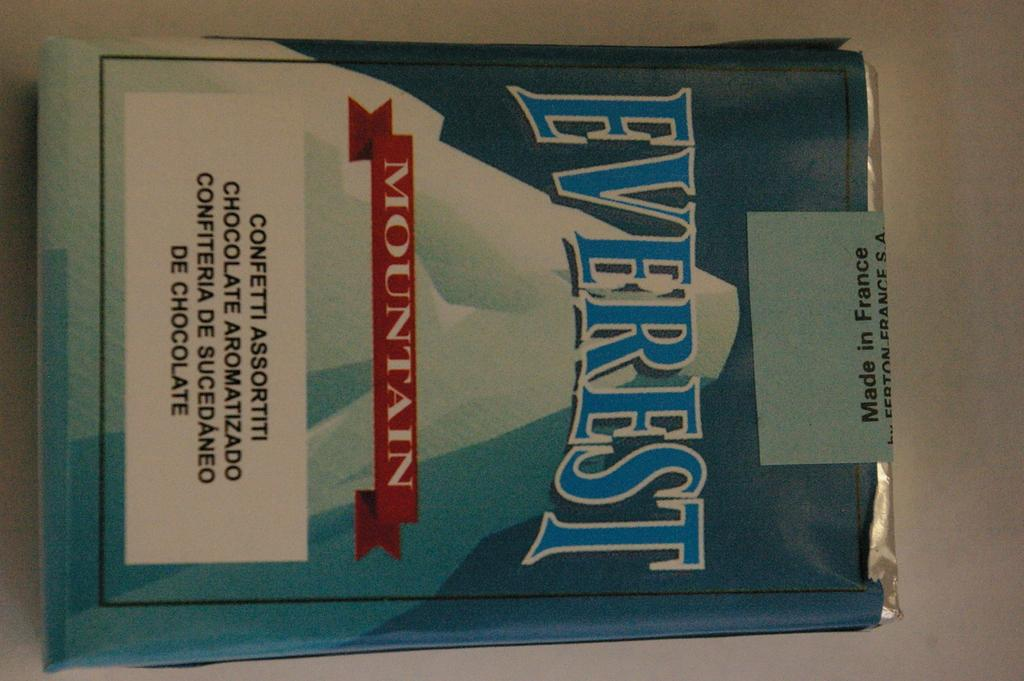<image>
Share a concise interpretation of the image provided. A package of Everest Mountain chocolate sits on a table 